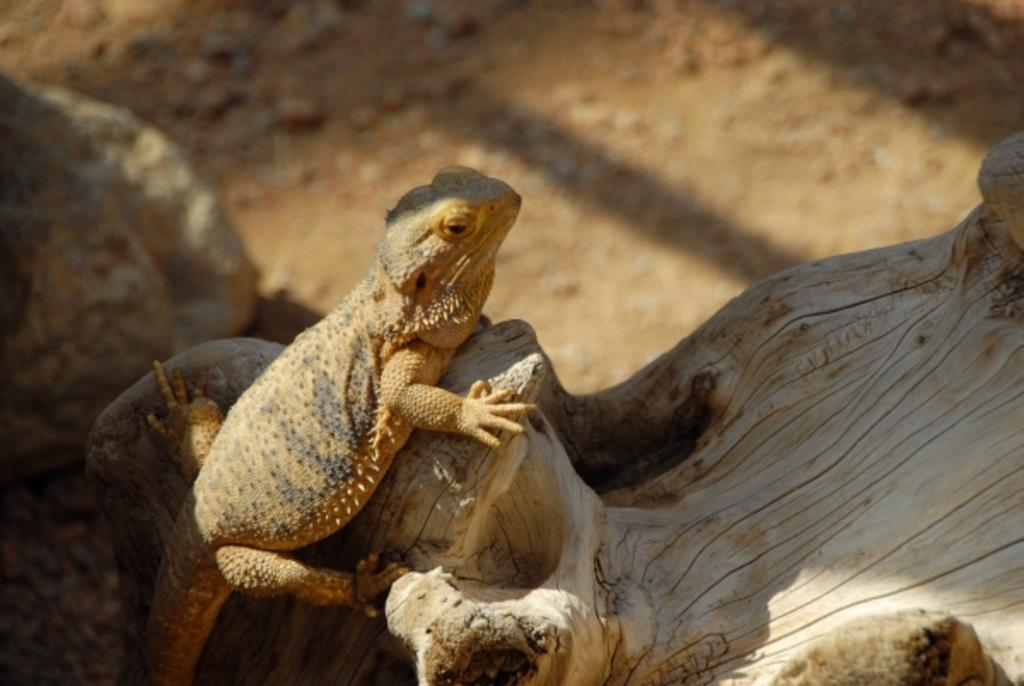What type of animal is in the image? There is a reptile in the image. Where is the reptile located in the image? The reptile is in the front of the image. What is at the bottom of the image? There is wood at the bottom of the image. What can be seen in the background of the image? There are stones visible in the background of the image. What color is the time displayed on the reptile's wrist in the image? There is no time or reptile's wrist present in the image, as it features a reptile in the front of the image with wood at the bottom and stones in the background. 